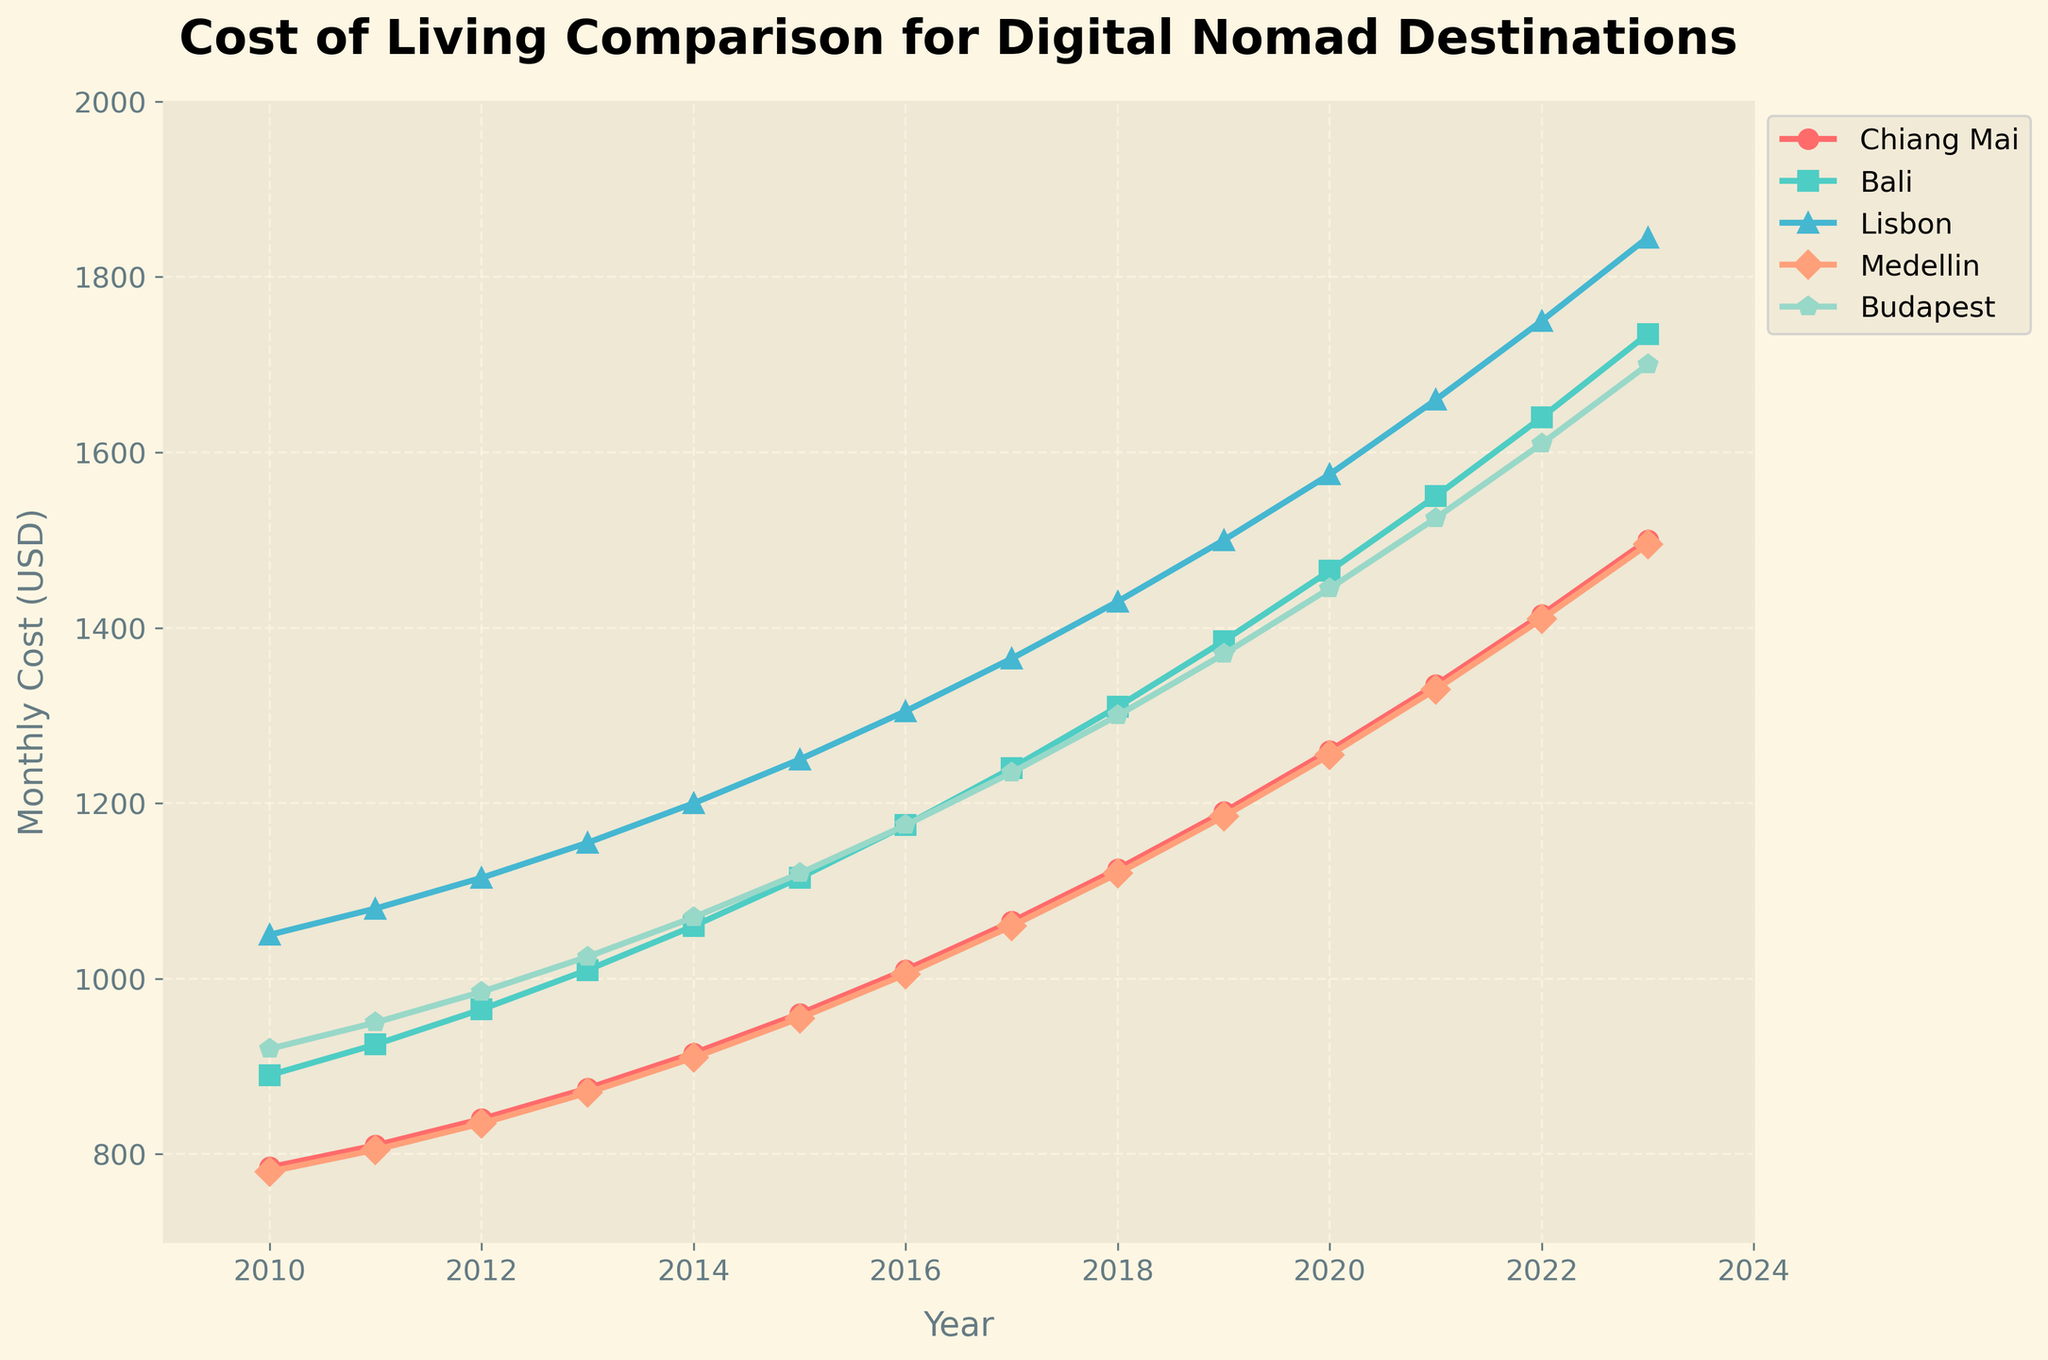What's the trend in the cost of living in Bali from 2010 to 2023? The line for Bali starts at $890 in 2010 and gradually increases to $1735 by 2023. This shows a consistent upward trend in the cost of living in Bali over the years.
Answer: Upward trend Which city had the lowest cost of living in 2010? In 2010, Chiang Mai and Medellin have the lowest monthly costs, both at $780.
Answer: Chiang Mai, Medellin By what percentage did the cost of living in Lisbon increase from 2010 to 2023? The cost of living in Lisbon increased from $1050 in 2010 to $1845 in 2023. The percentage increase is calculated as ((1845 - 1050) / 1050) * 100 = 75.71%.
Answer: 75.71% Which city's cost of living reached $1500 first, and in what year? Examining the lines in the plot, Lisbon first surpasses $1500 in the year 2019.
Answer: Lisbon, 2019 From 2016 to 2018, which city's cost of living increased the most? Looking at the differences: Chiang Mai (1125-1010)=115, Bali (1310-1175)=135, Lisbon (1430-1305)=125, Medellin (1120-1005)=115, Budapest (1300-1175)=125. Bali has the highest increase: 135.
Answer: Bali Is there a year when all cities had a cost of living increase compared to the previous year? By examining each year's data, all cities show an increase in cost of living every year from 2010 to 2023.
Answer: Every year In 2022, which city had the highest cost of living? In 2022, Lisbon has the highest cost of living at $1750.
Answer: Lisbon What is the difference in cost of living between Medellin and Budapest in 2023? In 2023, the cost of living in Medellin is $1495 and in Budapest it is $1700. The difference is 1700 - 1495 = $205.
Answer: $205 Which city shows the most consistent linear increase in the cost of living from 2010 to 2023? By observing the lines in the chart, Chiang Mai shows the most consistent linear increase, with a smooth and steady rise throughout the years.
Answer: Chiang Mai 